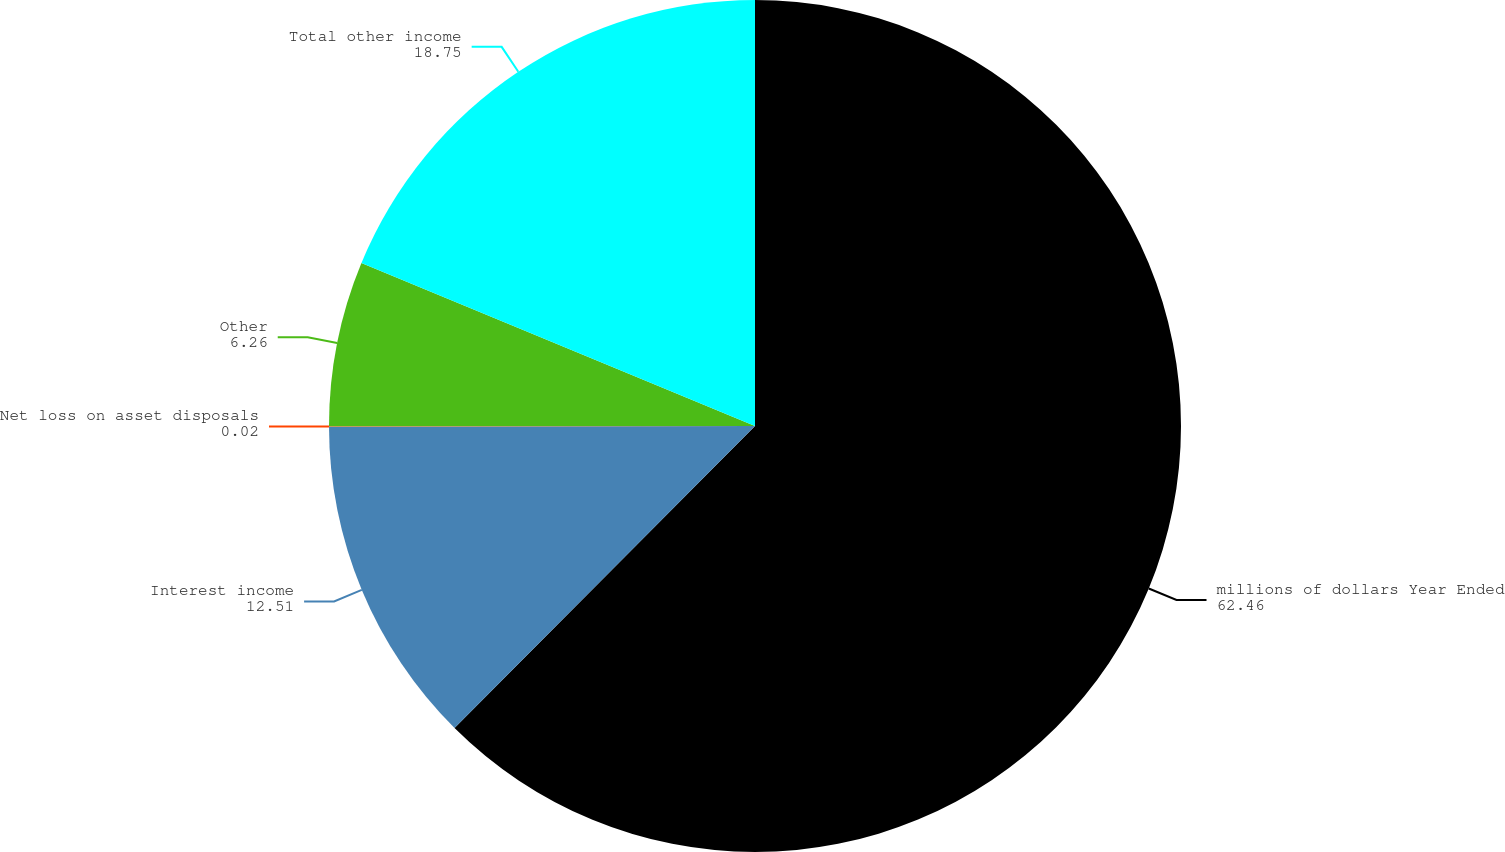<chart> <loc_0><loc_0><loc_500><loc_500><pie_chart><fcel>millions of dollars Year Ended<fcel>Interest income<fcel>Net loss on asset disposals<fcel>Other<fcel>Total other income<nl><fcel>62.46%<fcel>12.51%<fcel>0.02%<fcel>6.26%<fcel>18.75%<nl></chart> 